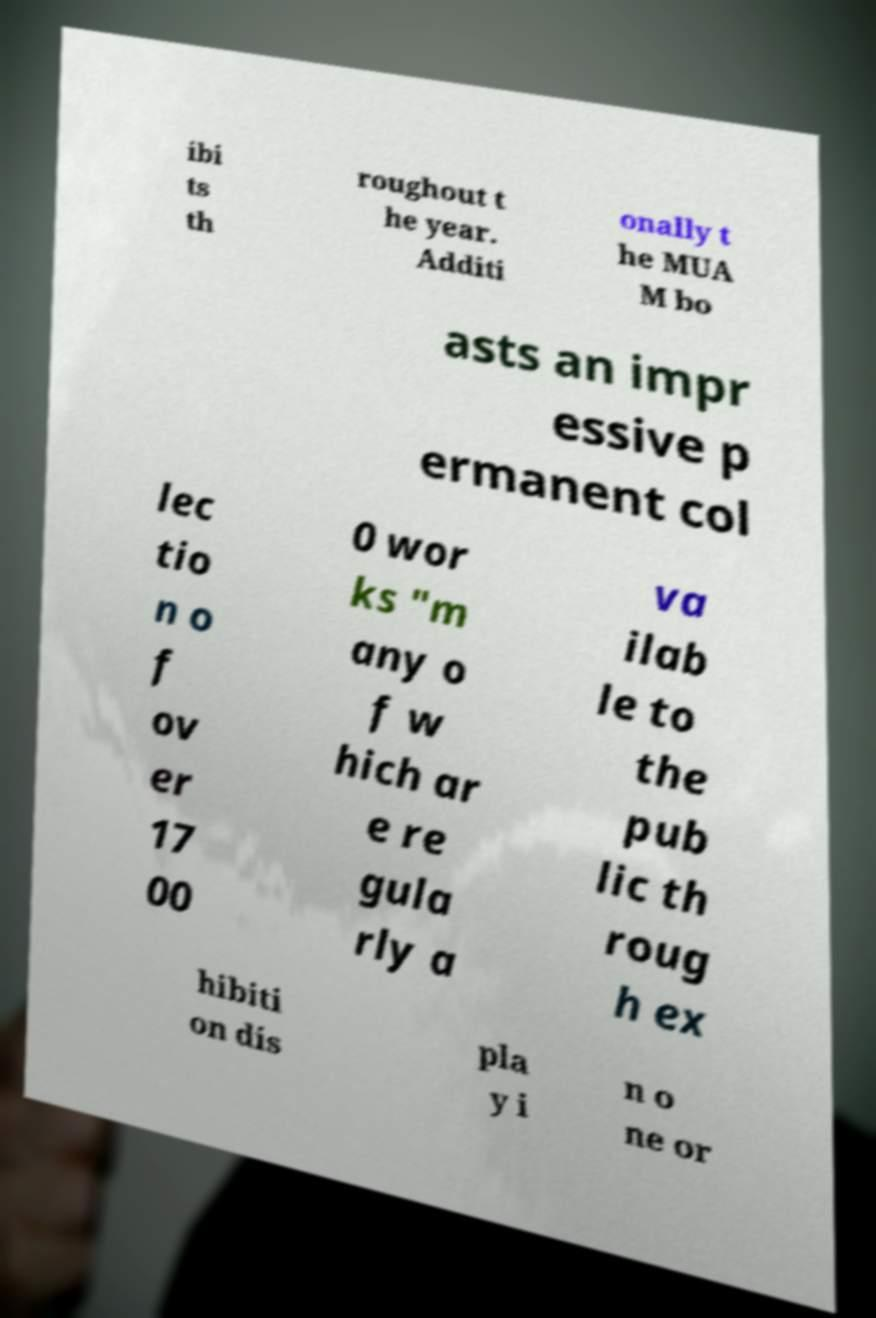Could you extract and type out the text from this image? ibi ts th roughout t he year. Additi onally t he MUA M bo asts an impr essive p ermanent col lec tio n o f ov er 17 00 0 wor ks "m any o f w hich ar e re gula rly a va ilab le to the pub lic th roug h ex hibiti on dis pla y i n o ne or 